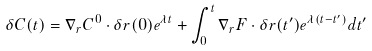<formula> <loc_0><loc_0><loc_500><loc_500>\delta { C } ( t ) = \nabla _ { r } { C ^ { 0 } } \cdot \delta { r } ( 0 ) e ^ { \lambda t } + \int _ { 0 } ^ { t } \nabla _ { r } { F } \cdot \delta { r } ( t ^ { \prime } ) e ^ { \lambda ( t - t ^ { \prime } ) } d t ^ { \prime }</formula> 